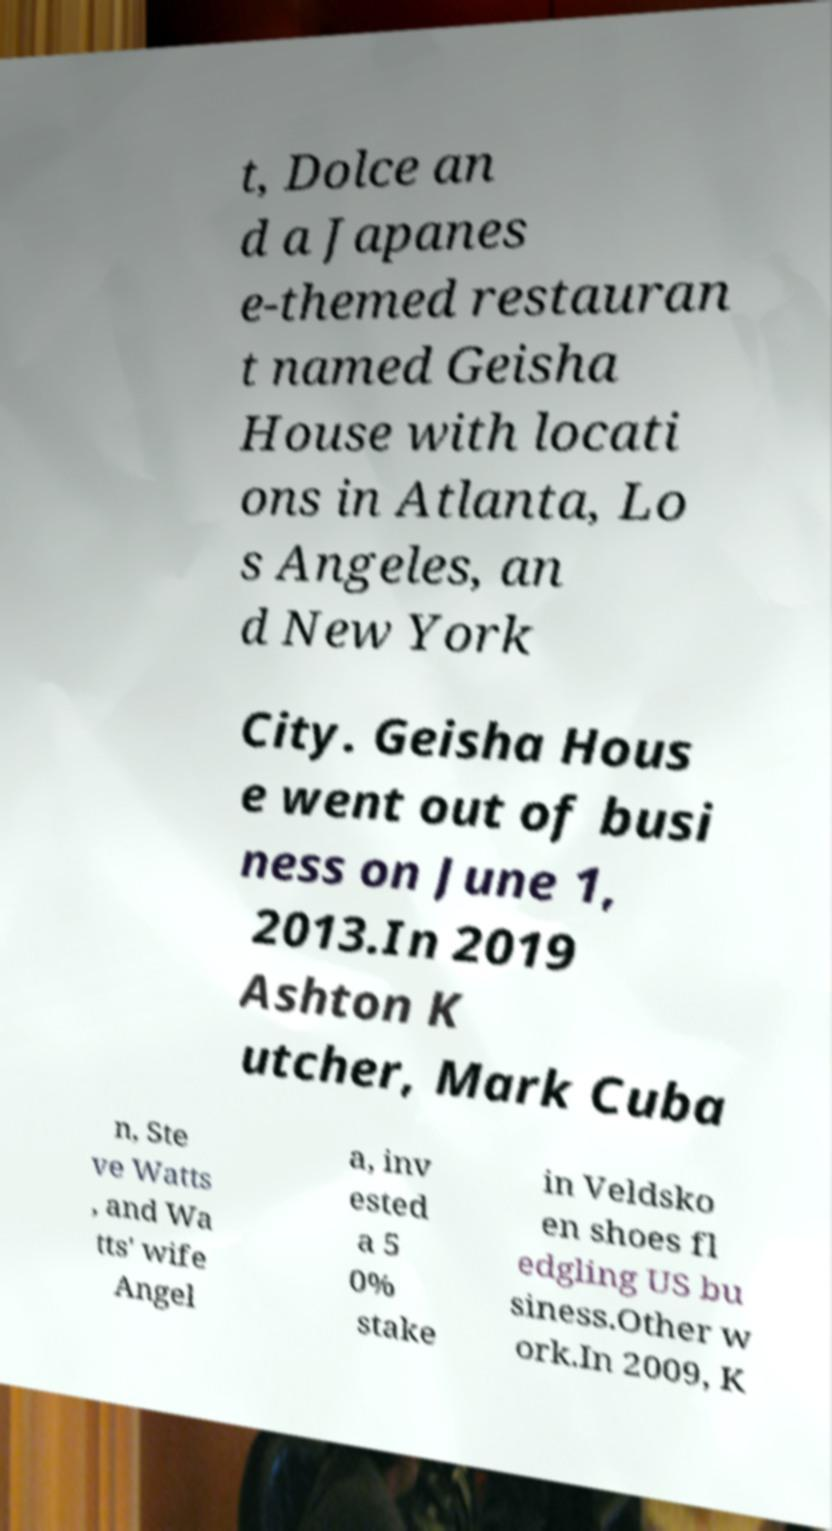Can you read and provide the text displayed in the image?This photo seems to have some interesting text. Can you extract and type it out for me? t, Dolce an d a Japanes e-themed restauran t named Geisha House with locati ons in Atlanta, Lo s Angeles, an d New York City. Geisha Hous e went out of busi ness on June 1, 2013.In 2019 Ashton K utcher, Mark Cuba n, Ste ve Watts , and Wa tts' wife Angel a, inv ested a 5 0% stake in Veldsko en shoes fl edgling US bu siness.Other w ork.In 2009, K 